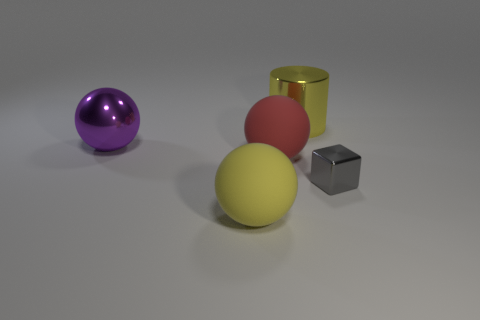What is the material of the gray block? metal 